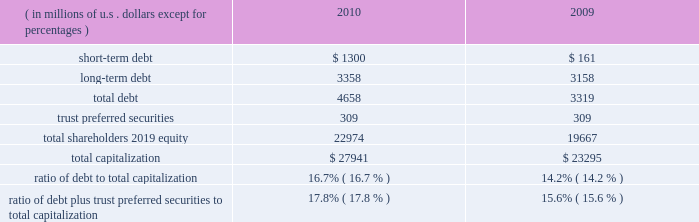Our consolidated net cash flows used for investing activities were $ 4.2 billion in 2010 , compared with $ 3.2 billion in 2009 .
Net investing activities for the indicated periods were related primarily to net purchases of fixed maturities and for 2010 included the acquisitions of rain and hail and jerneh insurance berhad .
Our consolidated net cash flows from financing activities were $ 732 million in 2010 , compared with net cash flows used for financing activities of $ 321 million in 2009 .
Net cash flows from/used for financing activities in 2010 and 2009 , included dividends paid on our common shares of $ 435 million and $ 388 million , respectively .
Net cash flows from financing activ- ities in 2010 , included net proceeds of $ 699 million from the issuance of long-term debt , $ 1 billion in reverse repurchase agreements , and $ 300 million in credit facility borrowings .
This was partially offset by repayment of $ 659 million in debt and share repurchases settled in 2010 of $ 235 million .
For 2009 , net cash flows used for financing activities included net pro- ceeds from the issuance of $ 500 million in long-term debt and the net repayment of debt and reverse repurchase agreements of $ 466 million .
Both internal and external forces influence our financial condition , results of operations , and cash flows .
Claim settle- ments , premium levels , and investment returns may be impacted by changing rates of inflation and other economic conditions .
In many cases , significant periods of time , ranging up to several years or more , may lapse between the occurrence of an insured loss , the reporting of the loss to us , and the settlement of the liability for that loss .
From time to time , we utilize reverse repurchase agreements as a low-cost alternative for short-term funding needs .
We use these instruments on a limited basis to address short-term cash timing differences without disrupting our investment portfolio holdings and settle the transactions with future operating cash flows .
At december 31 , 2010 , there were $ 1 billion in reverse repurchase agreements outstanding ( refer to short-term debt ) .
In addition to cash from operations , routine sales of investments , and financing arrangements , we have agreements with a bank provider which implemented two international multi-currency notional cash pooling programs to enhance cash management efficiency during periods of short-term timing mismatches between expected inflows and outflows of cash by currency .
In each program , participating ace entities establish deposit accounts in different currencies with the bank provider and each day the credit or debit balances in every account are notionally translated into a single currency ( u.s .
Dollars ) and then notionally pooled .
The bank extends overdraft credit to any participating ace entity as needed , provided that the overall notionally-pooled balance of all accounts in each pool at the end of each day is at least zero .
Actual cash balances are not physically converted and are not co-mingled between legal entities .
Ace entities may incur overdraft balances as a means to address short-term timing mismatches , and any overdraft balances incurred under this program by an ace entity would be guaranteed by ace limited ( up to $ 150 million in the aggregate ) .
Our revolving credit facility allows for same day drawings to fund a net pool overdraft should participating ace entities withdraw contributed funds from the pool .
Capital resources capital resources consist of funds deployed or available to be deployed to support our business operations .
The table summarizes the components of our capital resources at december 31 , 2010 , and 2009. .
Our ratios of debt to total capitalization and debt plus trust preferred securities to total capitalization have increased temporarily due to the increase in short-term debt , as discussed below .
We expect that these ratios will decline over the next six to nine months as we repay the short-term debt .
We believe our financial strength provides us with the flexibility and capacity to obtain available funds externally through debt or equity financing on both a short-term and long-term basis .
Our ability to access the capital markets is dependent on , among other things , market conditions and our perceived financial strength .
We have accessed both the debt and equity markets from time to time. .
What is the debt-asset ratio for 2010? 
Computations: (4658 / (4658 + 22974))
Answer: 0.16857. 